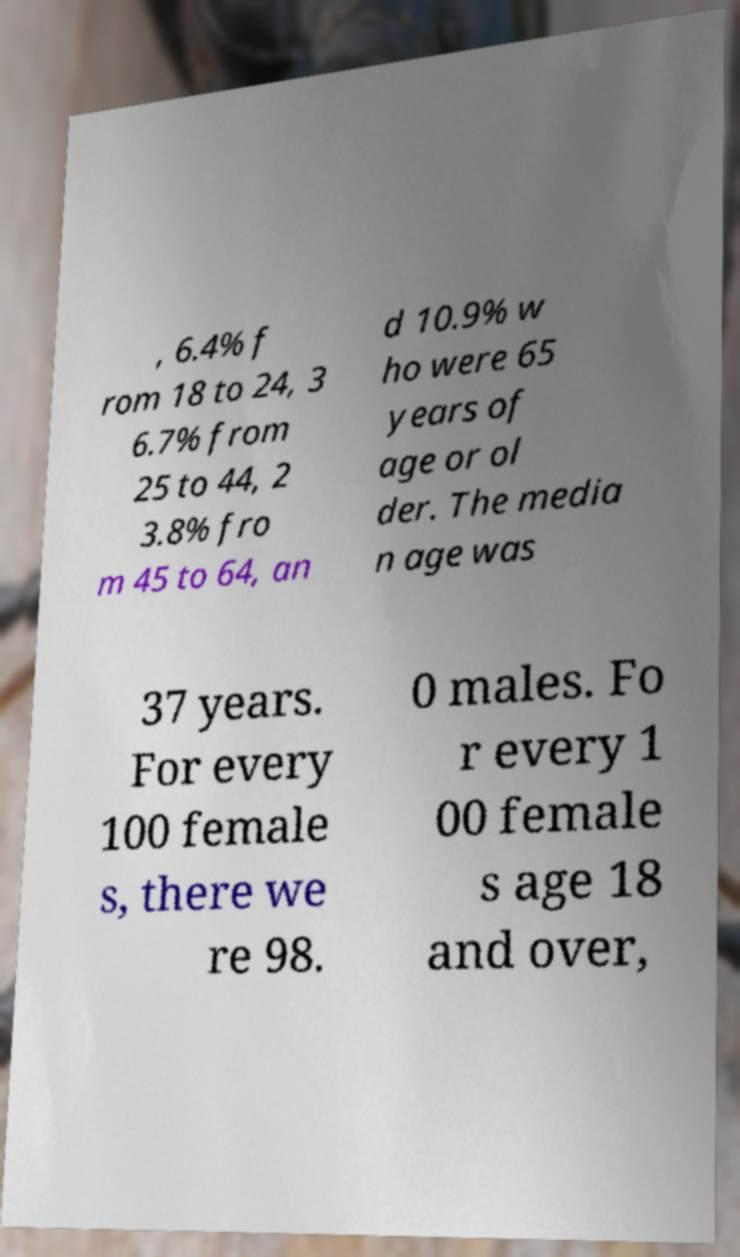Please read and relay the text visible in this image. What does it say? , 6.4% f rom 18 to 24, 3 6.7% from 25 to 44, 2 3.8% fro m 45 to 64, an d 10.9% w ho were 65 years of age or ol der. The media n age was 37 years. For every 100 female s, there we re 98. 0 males. Fo r every 1 00 female s age 18 and over, 